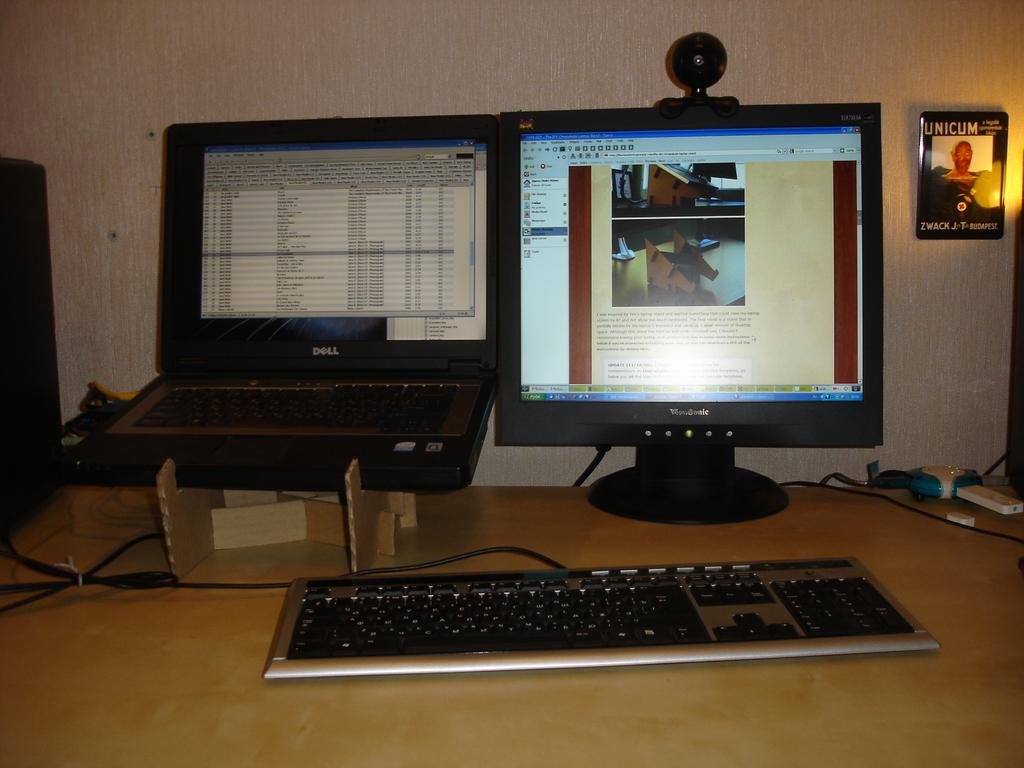What type of device is visible in the image? There is a keyboard in the image. What other electronic device can be seen in the image? There is a monitor in the image. Can you identify another type of computer in the image? Yes, there is a laptop in the image. Where are all these devices located? All of these objects are on a table. What color is the cream on the stem of the flower in the image? There is no flower or stem present in the image; it only features a keyboard, monitor, and laptop on a table. 